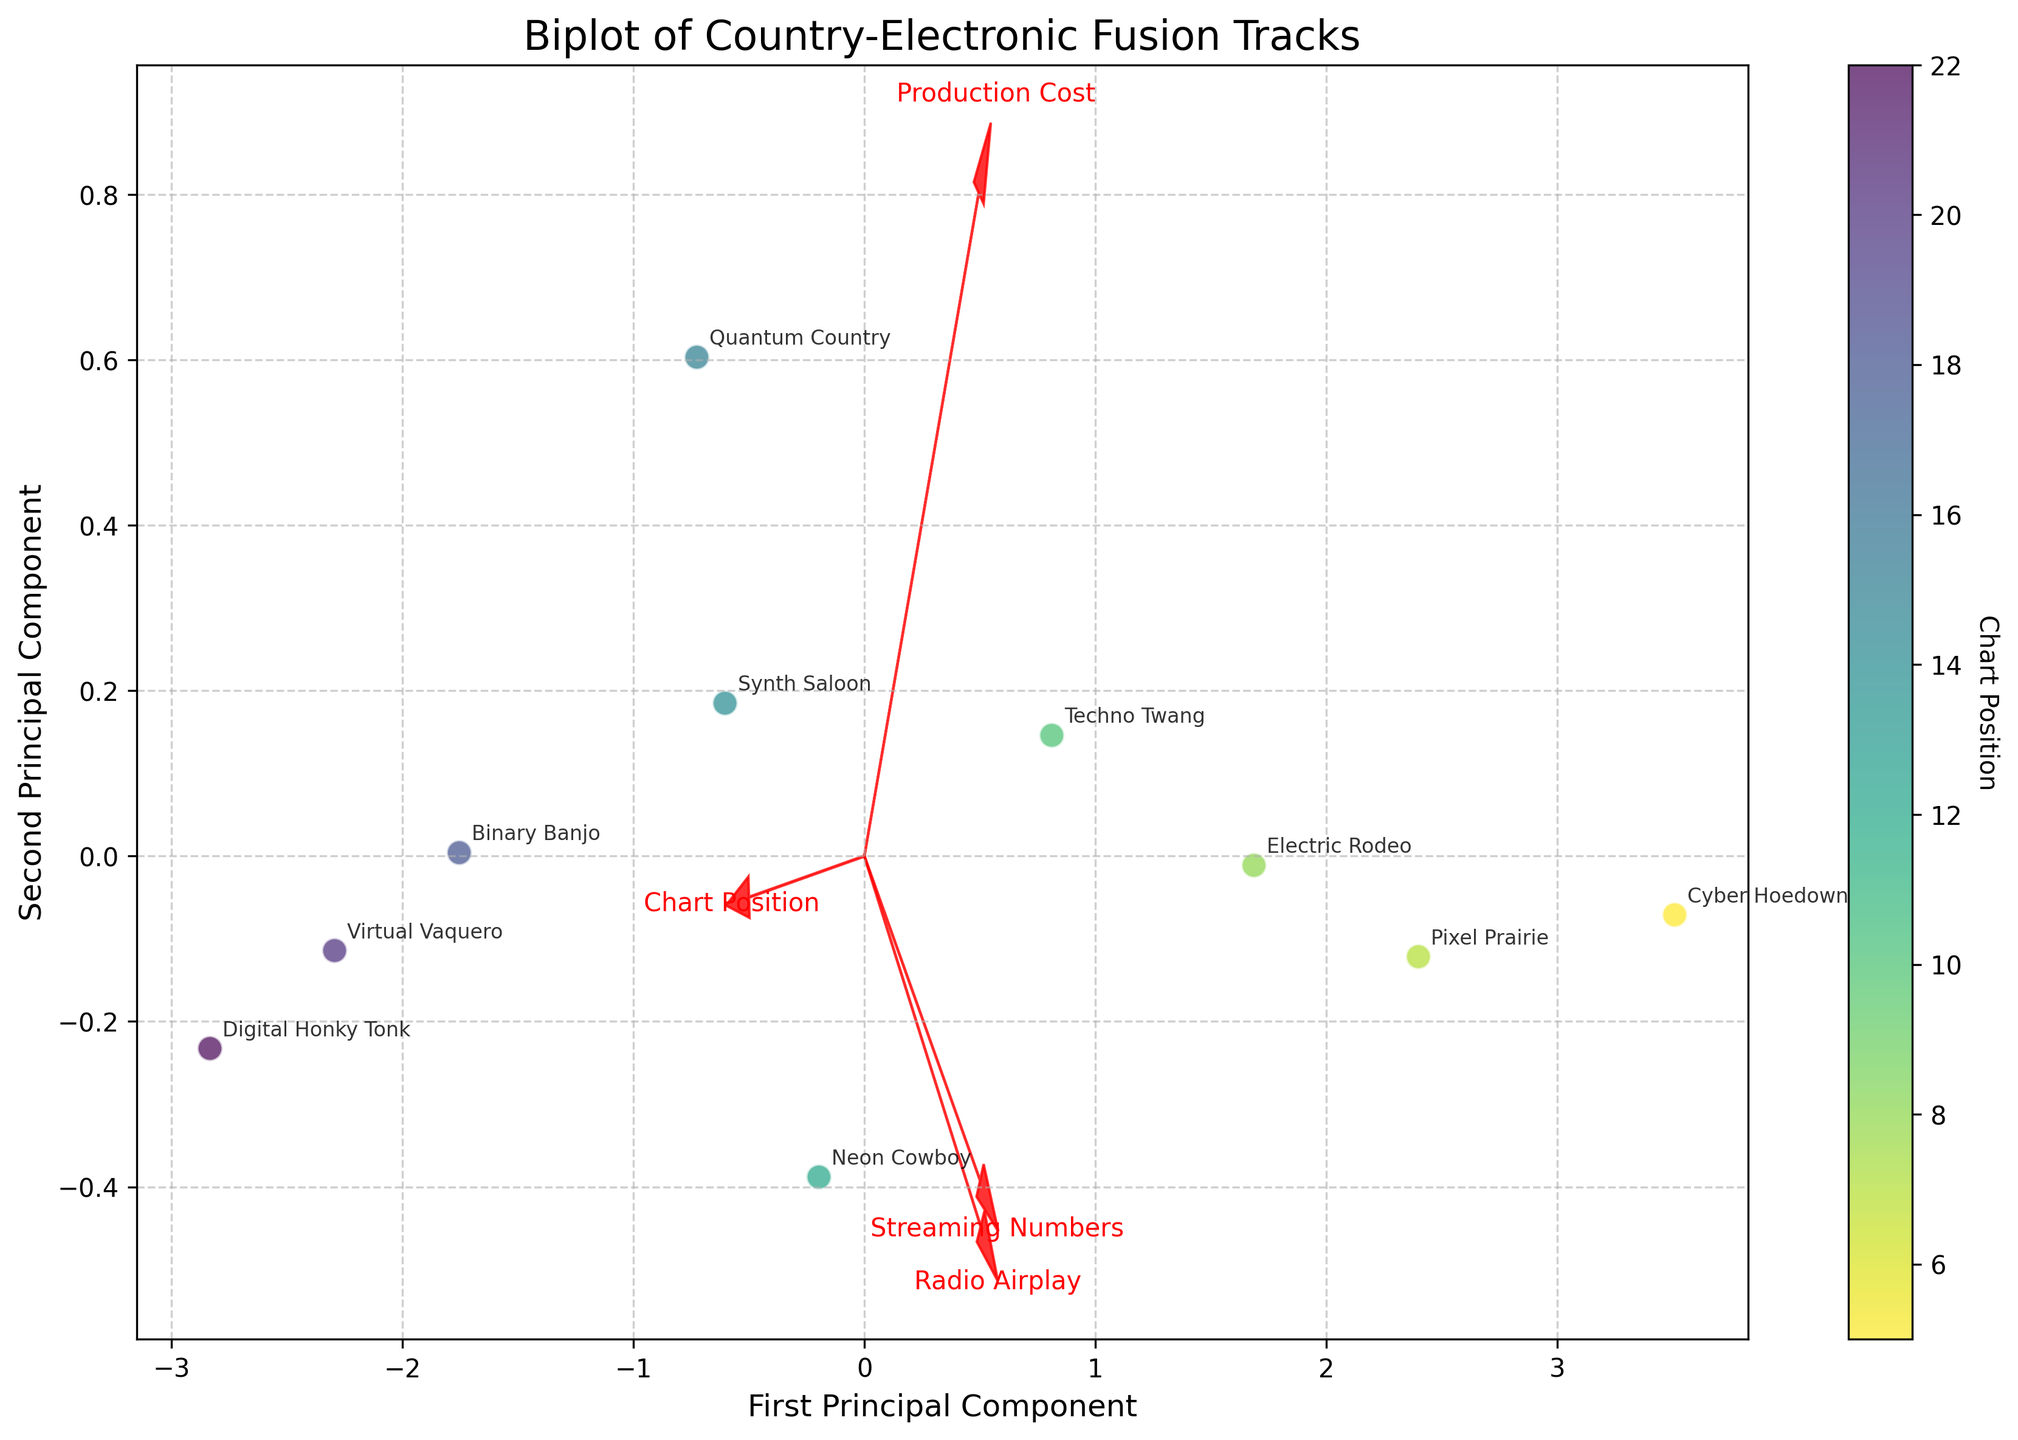what is the title of the biplot? The title is typically displayed at the top of the figure. Here, it reads 'Biplot of Country-Electronic Fusion Tracks'.
Answer: Biplot of Country-Electronic Fusion Tracks how many arrows are shown in the plot? Arrows in a biplot indicate the feature vectors. Each feature in our data is represented by an arrow. There are four features: 'Production Cost', 'Chart Position', 'Streaming Numbers', and 'Radio Airplay'.
Answer: 4 what feature does the arrow pointing closest to the bottom-left corner represent? By observing the direction in which the arrows point, the one closest to the bottom-left often represents a significant negative relationship with both principal components. In this plot, it is most likely 'Chart Position'.
Answer: Chart Position which track appears to have the lowest Chart Position based on the color gradient? The color gradient represents Chart Position, where lighter colors indicate lower positions (i.e., better ranking). 'Cyber Hoedown' appears closest to the bottom of the color scale.
Answer: Cyber Hoedown which tracks' points are closest to each other in the plot? Look for points that are visually near each other. 'Neon Cowboy' and 'Binary Banjo' appear to be very close.
Answer: Neon Cowboy, Binary Banjo is there a positive relationship between production cost and streaming numbers in the first principal component? Check the directions of the arrows for 'Production Cost' and 'Streaming Numbers'. If they point roughly in the same direction along the first principal component, they have a positive relationship.
Answer: Yes which feature is contributing most to the first principal component based on arrow length? The feature with the longest arrow in the direction of the first principal component contributes the most. 'Streaming Numbers' has the longest arrow along this component.
Answer: Streaming Numbers do tracks with higher radio airplay generally rank better (lower chart positions)? Comparing the direction of 'Radio Airplay' with 'Chart Position' can reveal if tracks with higher airplay have better rankings. Since they point in roughly opposite directions, there's a negative relationship. Higher radio airplay tends to correlate with better (lower) rankings.
Answer: Yes how does the track 'Virtual Vaquero' compare in terms of streaming numbers? By checking the position of 'Virtual Vaquero' relative to the arrow of 'Streaming Numbers', it shows that 'Virtual Vaquero' has moderately low streaming numbers compared to others.
Answer: Moderately low can you identify a track with high production costs but lower chart ranking? Look for a point associated with high 'Production Cost' but with a higher (worse) chart position number. 'Quantum Country' has high production costs and is ranked 15th.
Answer: Quantum Country 